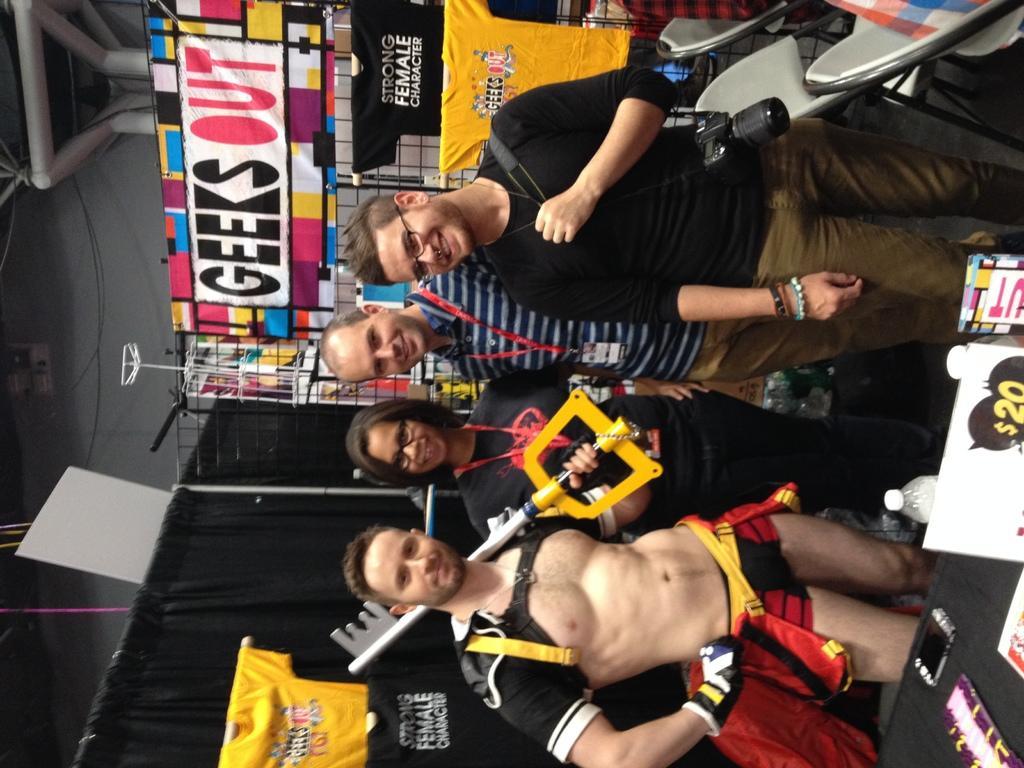In one or two sentences, can you explain what this image depicts? In this image I can see four persons are standing and I can see two of them are wearing specs. I can see the top one is carrying a camera. Behind them I can see a board, number of t shirts, chairs and on the board I can see something is written. In the front I can see a table and on it I can see a phone, a board, a bottle and few other stuffs. 